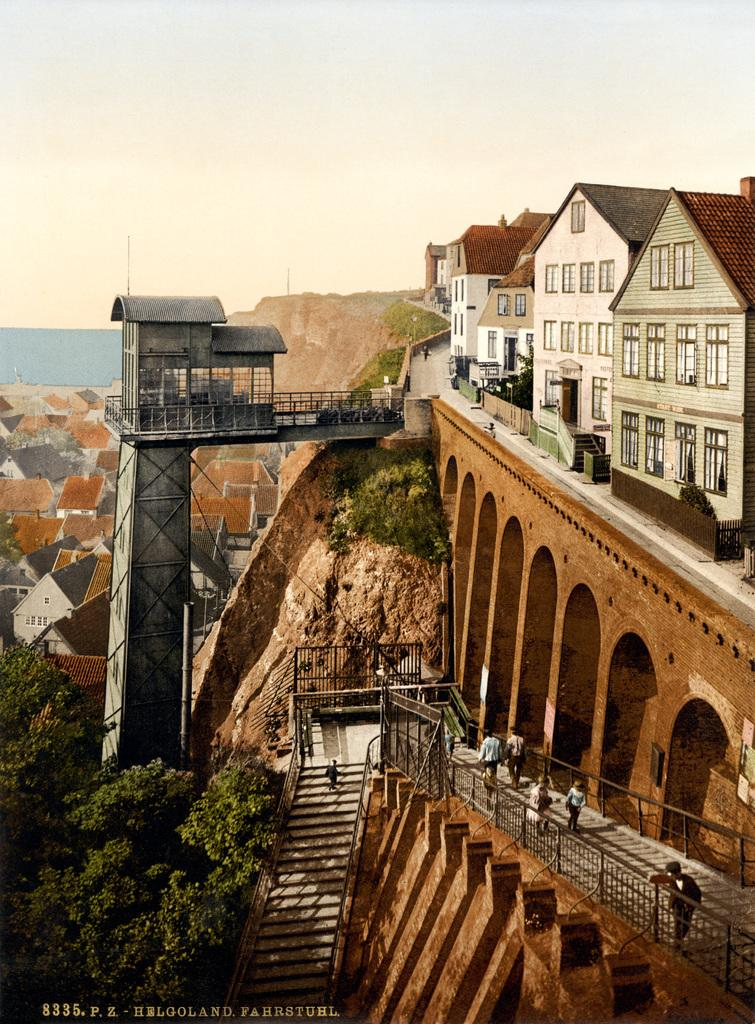What type of structures can be seen in the image? There are buildings in the image. What natural elements are present at the bottom of the image? There are trees at the bottom of the image. What architectural feature is visible in the image? There is a bridge visible in the image. What are the people in the image doing? People are walking in the image. Are there any stairs present in the image? Yes, there are stairs in the image. What can be seen in the background of the image? There are hills and the sky visible in the background of the image. How many cows are grazing on the hills in the background of the image? There are no cows present in the image; only buildings, trees, a bridge, people, stairs, hills, and the sky are visible. 